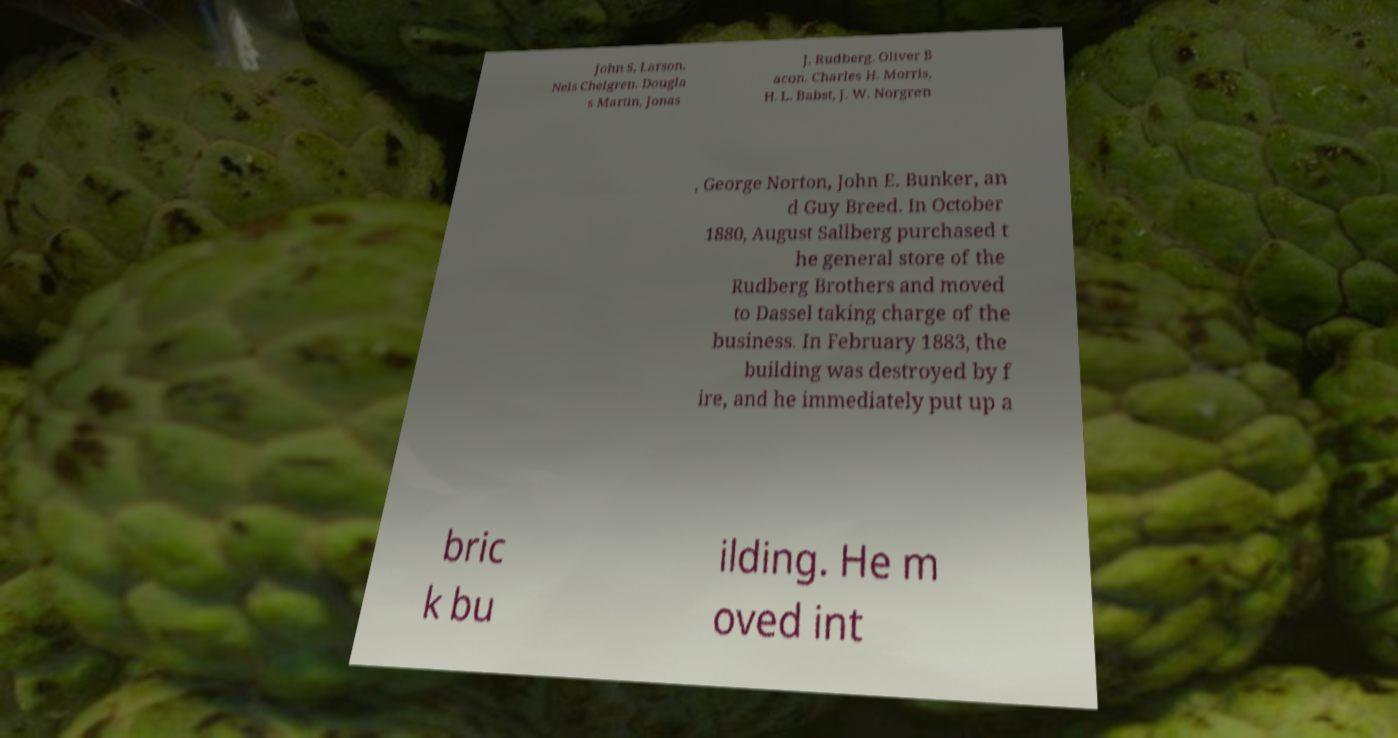There's text embedded in this image that I need extracted. Can you transcribe it verbatim? John S. Larson. Nels Chelgren. Dougla s Martin, Jonas J. Rudberg. Oliver B acon. Charles H. Morris, H. L. Babst, J. W. Norgren , George Norton, John E. Bunker, an d Guy Breed. In October 1880, August Sallberg purchased t he general store of the Rudberg Brothers and moved to Dassel taking charge of the business. In February 1883, the building was destroyed by f ire, and he immediately put up a bric k bu ilding. He m oved int 